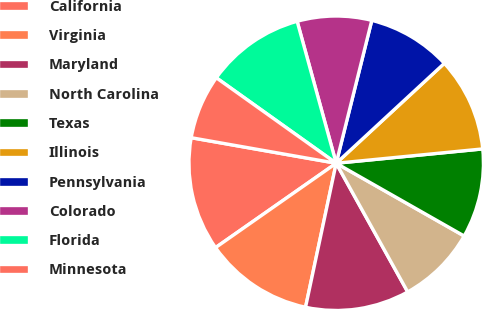Convert chart. <chart><loc_0><loc_0><loc_500><loc_500><pie_chart><fcel>California<fcel>Virginia<fcel>Maryland<fcel>North Carolina<fcel>Texas<fcel>Illinois<fcel>Pennsylvania<fcel>Colorado<fcel>Florida<fcel>Minnesota<nl><fcel>12.49%<fcel>11.95%<fcel>11.41%<fcel>8.7%<fcel>9.78%<fcel>10.32%<fcel>9.24%<fcel>8.16%<fcel>10.87%<fcel>7.08%<nl></chart> 